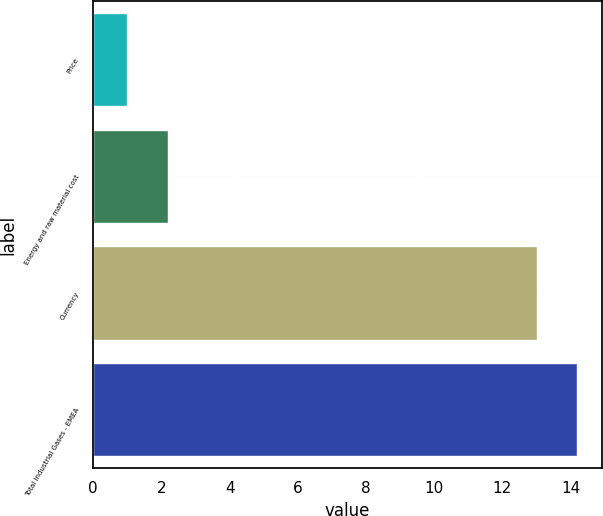Convert chart. <chart><loc_0><loc_0><loc_500><loc_500><bar_chart><fcel>Price<fcel>Energy and raw material cost<fcel>Currency<fcel>Total Industrial Gases - EMEA<nl><fcel>1<fcel>2.2<fcel>13<fcel>14.2<nl></chart> 